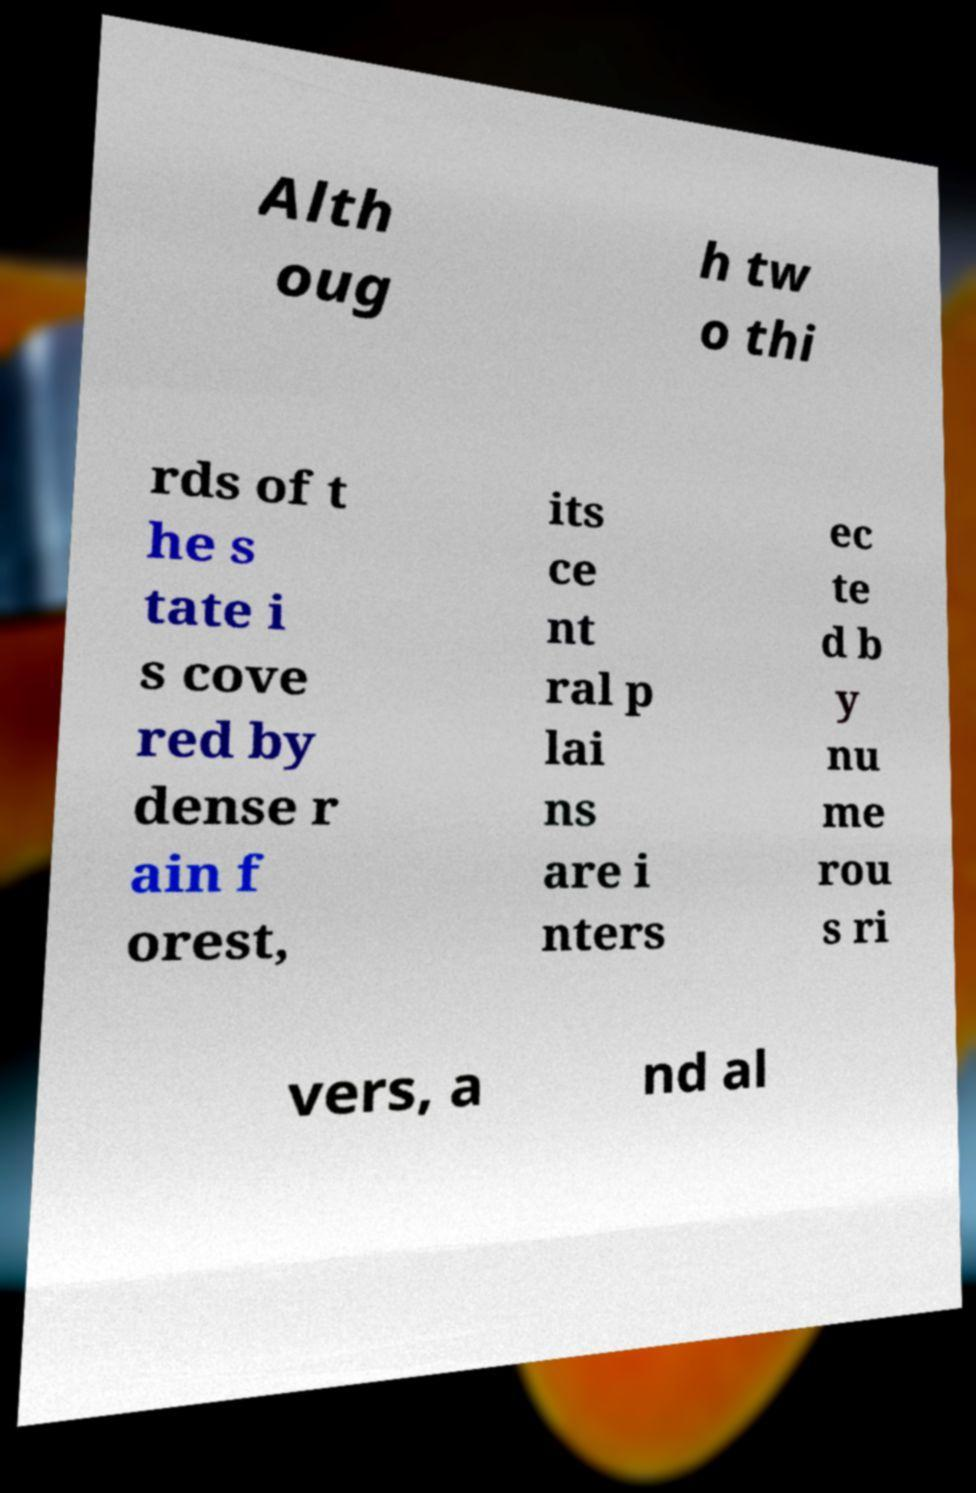Please read and relay the text visible in this image. What does it say? Alth oug h tw o thi rds of t he s tate i s cove red by dense r ain f orest, its ce nt ral p lai ns are i nters ec te d b y nu me rou s ri vers, a nd al 